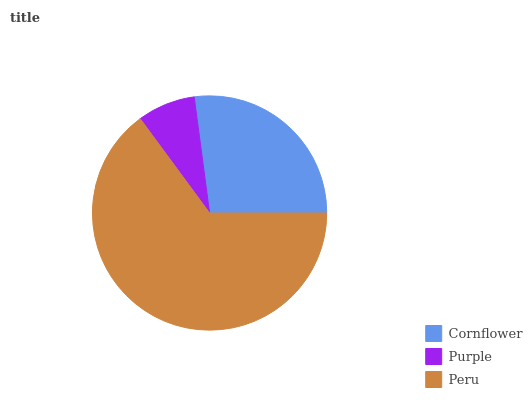Is Purple the minimum?
Answer yes or no. Yes. Is Peru the maximum?
Answer yes or no. Yes. Is Peru the minimum?
Answer yes or no. No. Is Purple the maximum?
Answer yes or no. No. Is Peru greater than Purple?
Answer yes or no. Yes. Is Purple less than Peru?
Answer yes or no. Yes. Is Purple greater than Peru?
Answer yes or no. No. Is Peru less than Purple?
Answer yes or no. No. Is Cornflower the high median?
Answer yes or no. Yes. Is Cornflower the low median?
Answer yes or no. Yes. Is Purple the high median?
Answer yes or no. No. Is Purple the low median?
Answer yes or no. No. 